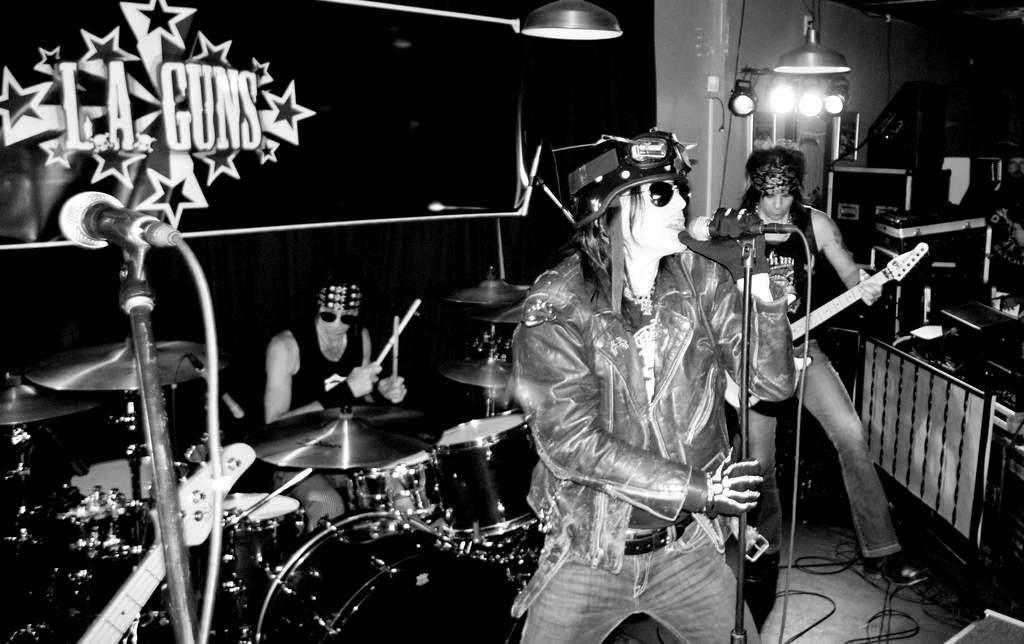How many people are in the image? There are three men in the image. What are the men doing in the image? One man is playing the guitar, another man is playing the drums, and a person is singing on a microphone. What can be seen in the background of the image? There is a banner, lights, and a piano in the background. Can you see a ghost playing the boot in the image? No, there is no ghost or boot present in the image. 